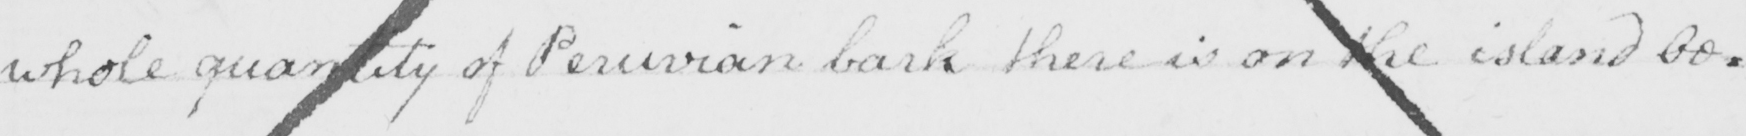What is written in this line of handwriting? whole quantity of Peruvian bask there is on the island be : 